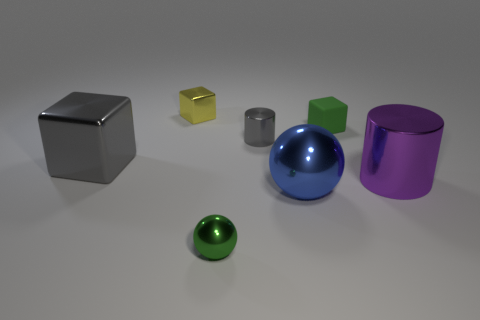There is a thing that is the same color as the big block; what is its material?
Keep it short and to the point. Metal. How many other things are there of the same color as the big shiny sphere?
Make the answer very short. 0. How many other objects are the same material as the yellow cube?
Your answer should be very brief. 5. There is a green ball; is its size the same as the thing that is to the right of the green rubber thing?
Make the answer very short. No. What color is the small matte thing?
Your answer should be compact. Green. The gray metal thing left of the small green thing that is in front of the thing that is on the right side of the green matte block is what shape?
Your answer should be compact. Cube. There is a tiny cube that is to the right of the thing behind the small matte cube; what is it made of?
Your answer should be compact. Rubber. The yellow object that is the same material as the big blue thing is what shape?
Give a very brief answer. Cube. Is there any other thing that is the same shape as the yellow metallic thing?
Provide a short and direct response. Yes. There is a small green ball; how many gray metal things are right of it?
Your answer should be compact. 1. 